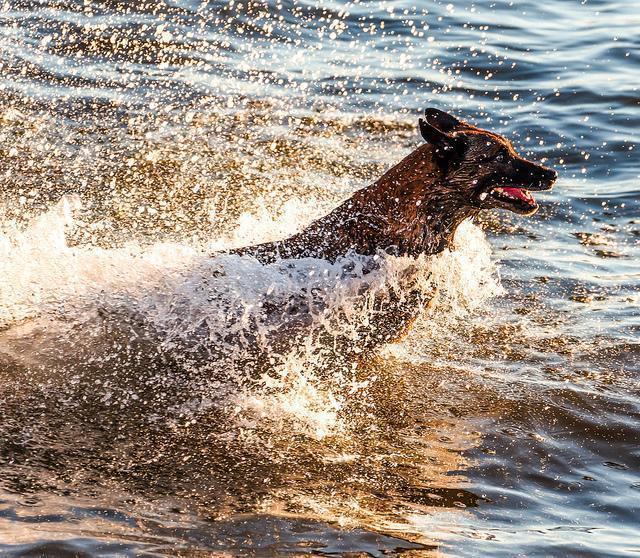How many birds are in the picture?
Give a very brief answer. 0. 